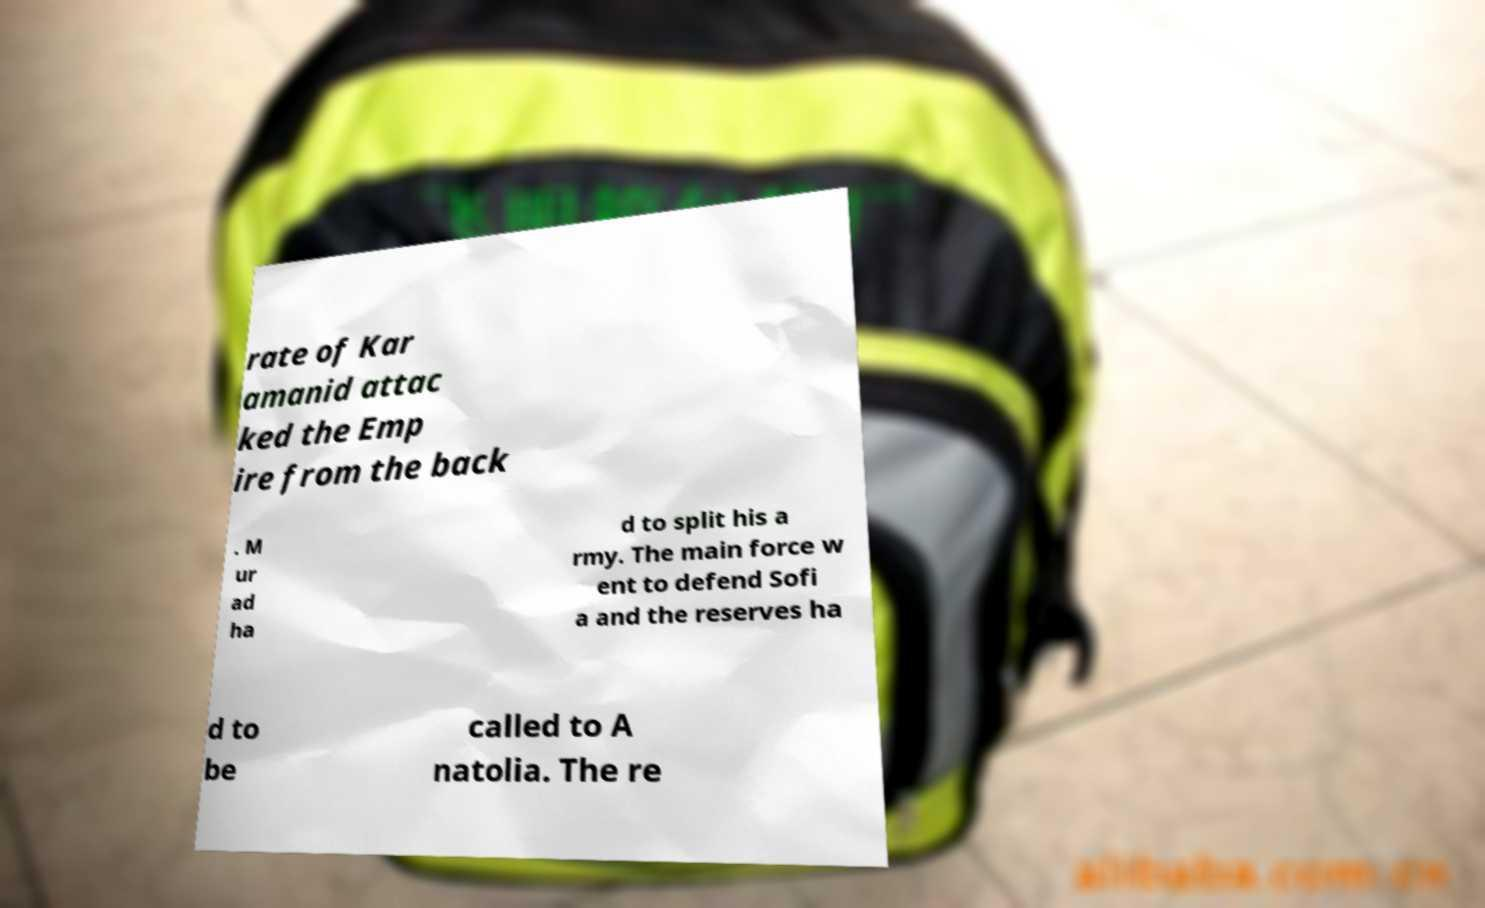Can you accurately transcribe the text from the provided image for me? rate of Kar amanid attac ked the Emp ire from the back . M ur ad ha d to split his a rmy. The main force w ent to defend Sofi a and the reserves ha d to be called to A natolia. The re 